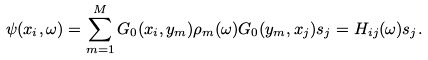Convert formula to latex. <formula><loc_0><loc_0><loc_500><loc_500>\psi ( x _ { i } , \omega ) = \sum _ { m = 1 } ^ { M } G _ { 0 } ( x _ { i } , y _ { m } ) \rho _ { m } ( \omega ) G _ { 0 } ( y _ { m } , x _ { j } ) s _ { j } = H _ { i j } ( \omega ) s _ { j } .</formula> 